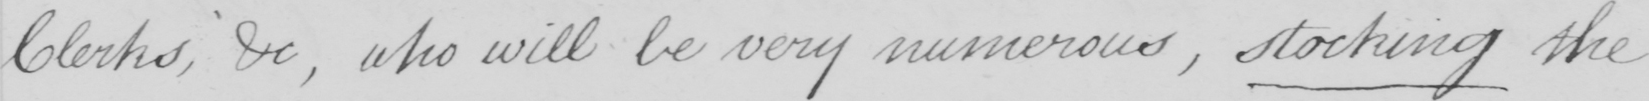What text is written in this handwritten line? Clerks , &c , who will be very numerous , stocking the 